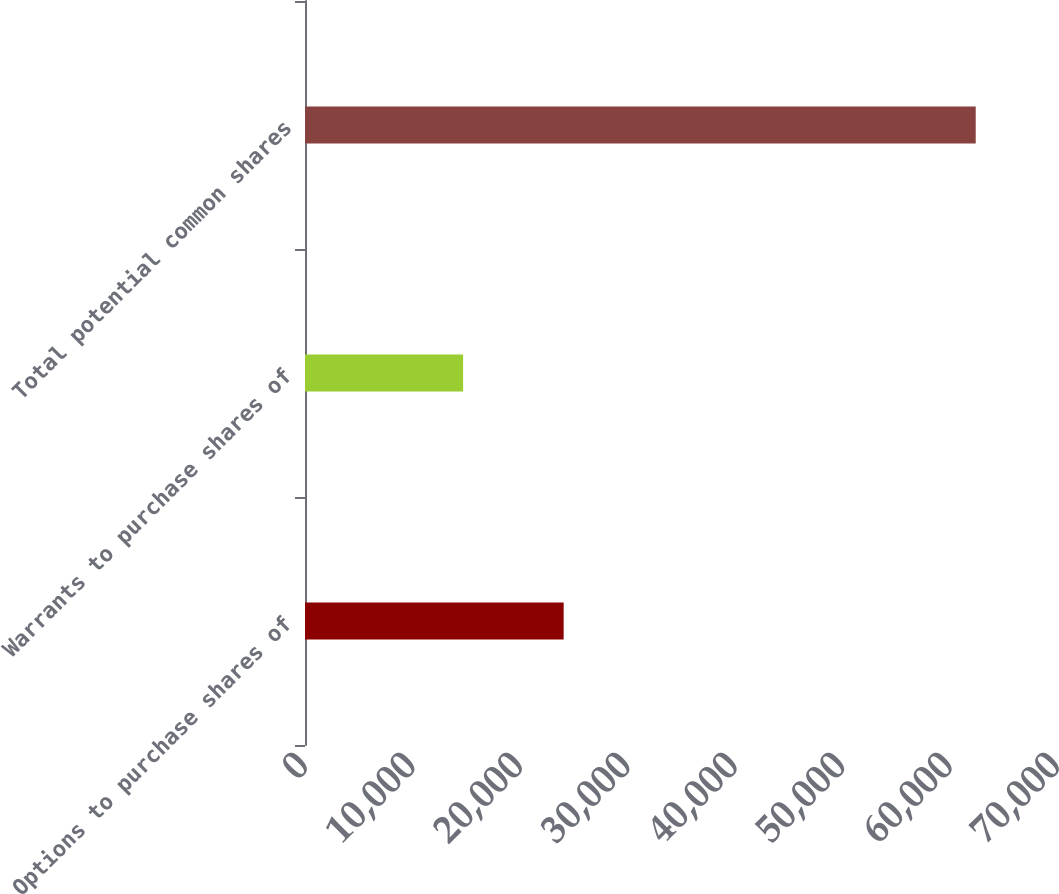Convert chart. <chart><loc_0><loc_0><loc_500><loc_500><bar_chart><fcel>Options to purchase shares of<fcel>Warrants to purchase shares of<fcel>Total potential common shares<nl><fcel>24077<fcel>14717<fcel>62434<nl></chart> 